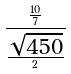Convert formula to latex. <formula><loc_0><loc_0><loc_500><loc_500>\frac { \frac { 1 0 } { 7 } } { \frac { \sqrt { 4 5 0 } } { 2 } }</formula> 